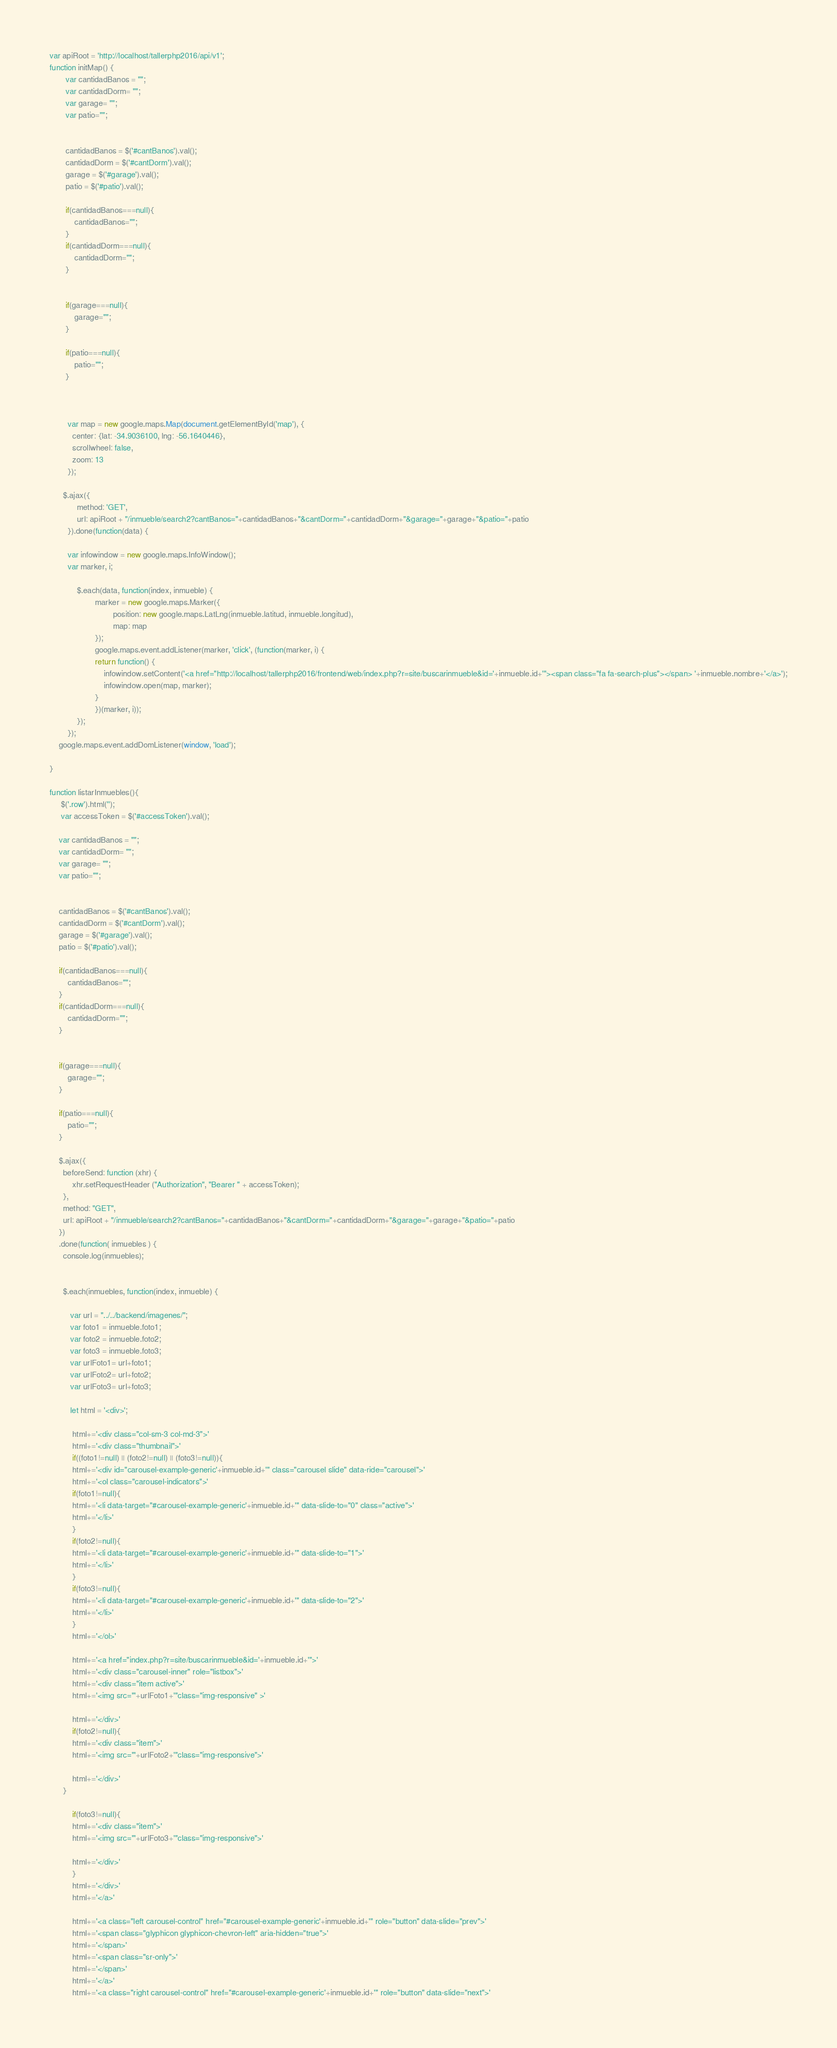<code> <loc_0><loc_0><loc_500><loc_500><_JavaScript_>var apiRoot = 'http://localhost/tallerphp2016/api/v1';
function initMap() {
       var cantidadBanos = "";
       var cantidadDorm= "";
       var garage= "";
       var patio="";


       cantidadBanos = $('#cantBanos').val();
       cantidadDorm = $('#cantDorm').val();
       garage = $('#garage').val();
       patio = $('#patio').val();

       if(cantidadBanos===null){
           cantidadBanos="";
       }
       if(cantidadDorm===null){
           cantidadDorm="";
       }


       if(garage===null){
           garage="";
       }

       if(patio===null){
           patio="";
       }
     
          
        
        var map = new google.maps.Map(document.getElementById('map'), {
          center: {lat: -34.9036100, lng: -56.1640446}, 
          scrollwheel: false,
          zoom: 13
        });
       
      $.ajax({
            method: 'GET',
            url: apiRoot + "/inmueble/search2?cantBanos="+cantidadBanos+"&cantDorm="+cantidadDorm+"&garage="+garage+"&patio="+patio
        }).done(function(data) {
        
        var infowindow = new google.maps.InfoWindow();
        var marker, i;
        
            $.each(data, function(index, inmueble) {
                    marker = new google.maps.Marker({
                            position: new google.maps.LatLng(inmueble.latitud, inmueble.longitud),
                            map: map
                    });
                    google.maps.event.addListener(marker, 'click', (function(marker, i) {
                    return function() {
                        infowindow.setContent('<a href="http://localhost/tallerphp2016/frontend/web/index.php?r=site/buscarinmueble&id='+inmueble.id+'"><span class="fa fa-search-plus"></span> '+inmueble.nombre+'</a>');
                        infowindow.open(map, marker);
                    }
                    })(marker, i));
            });
        });
    google.maps.event.addDomListener(window, 'load');       

}  

function listarInmuebles(){
     $('.row').html('');
     var accessToken = $('#accessToken').val();
     
    var cantidadBanos = "";
    var cantidadDorm= "";
    var garage= "";
    var patio="";


    cantidadBanos = $('#cantBanos').val();
    cantidadDorm = $('#cantDorm').val();
    garage = $('#garage').val();
    patio = $('#patio').val();

    if(cantidadBanos===null){
        cantidadBanos="";
    }
    if(cantidadDorm===null){
        cantidadDorm="";
    }


    if(garage===null){
        garage="";
    }

    if(patio===null){
        patio="";
    }
    
    $.ajax({
      beforeSend: function (xhr) {
          xhr.setRequestHeader ("Authorization", "Bearer " + accessToken);
      },
      method: "GET",
      url: apiRoot + "/inmueble/search2?cantBanos="+cantidadBanos+"&cantDorm="+cantidadDorm+"&garage="+garage+"&patio="+patio
    })
    .done(function( inmuebles ) {
      console.log(inmuebles);


      $.each(inmuebles, function(index, inmueble) {

         var url = "../../backend/imagenes/";
         var foto1 = inmueble.foto1;
         var foto2 = inmueble.foto2;
         var foto3 = inmueble.foto3;
         var urlFoto1= url+foto1;
         var urlFoto2= url+foto2;
         var urlFoto3= url+foto3;

         let html = '<div>';     

          html+='<div class="col-sm-3 col-md-3">'
          html+='<div class="thumbnail">'
          if((foto1!=null) || (foto2!=null) || (foto3!=null)){
          html+='<div id="carousel-example-generic'+inmueble.id+'" class="carousel slide" data-ride="carousel">'
          html+='<ol class="carousel-indicators">'
          if(foto1!=null){
          html+='<li data-target="#carousel-example-generic'+inmueble.id+'" data-slide-to="0" class="active">'
          html+='</li>'
          }
          if(foto2!=null){
          html+='<li data-target="#carousel-example-generic'+inmueble.id+'" data-slide-to="1">'
          html+='</li>'
          }
          if(foto3!=null){
          html+='<li data-target="#carousel-example-generic'+inmueble.id+'" data-slide-to="2">'
          html+='</li>'
          }
          html+='</ol>'

          html+='<a href="index.php?r=site/buscarinmueble&id='+inmueble.id+'">'
          html+='<div class="carousel-inner" role="listbox">'
          html+='<div class="item active">'
          html+='<img src="'+urlFoto1+'"class="img-responsive" >'

          html+='</div>'
          if(foto2!=null){
          html+='<div class="item">'
          html+='<img src="'+urlFoto2+'"class="img-responsive">'

          html+='</div>'
      }

          if(foto3!=null){
          html+='<div class="item">'
          html+='<img src="'+urlFoto3+'"class="img-responsive">'

          html+='</div>'
          }
          html+='</div>'
          html+='</a>'

          html+='<a class="left carousel-control" href="#carousel-example-generic'+inmueble.id+'" role="button" data-slide="prev">'
          html+='<span class="glyphicon glyphicon-chevron-left" aria-hidden="true">'
          html+='</span>'
          html+='<span class="sr-only">'
          html+='</span>'
          html+='</a>'
          html+='<a class="right carousel-control" href="#carousel-example-generic'+inmueble.id+'" role="button" data-slide="next">'</code> 